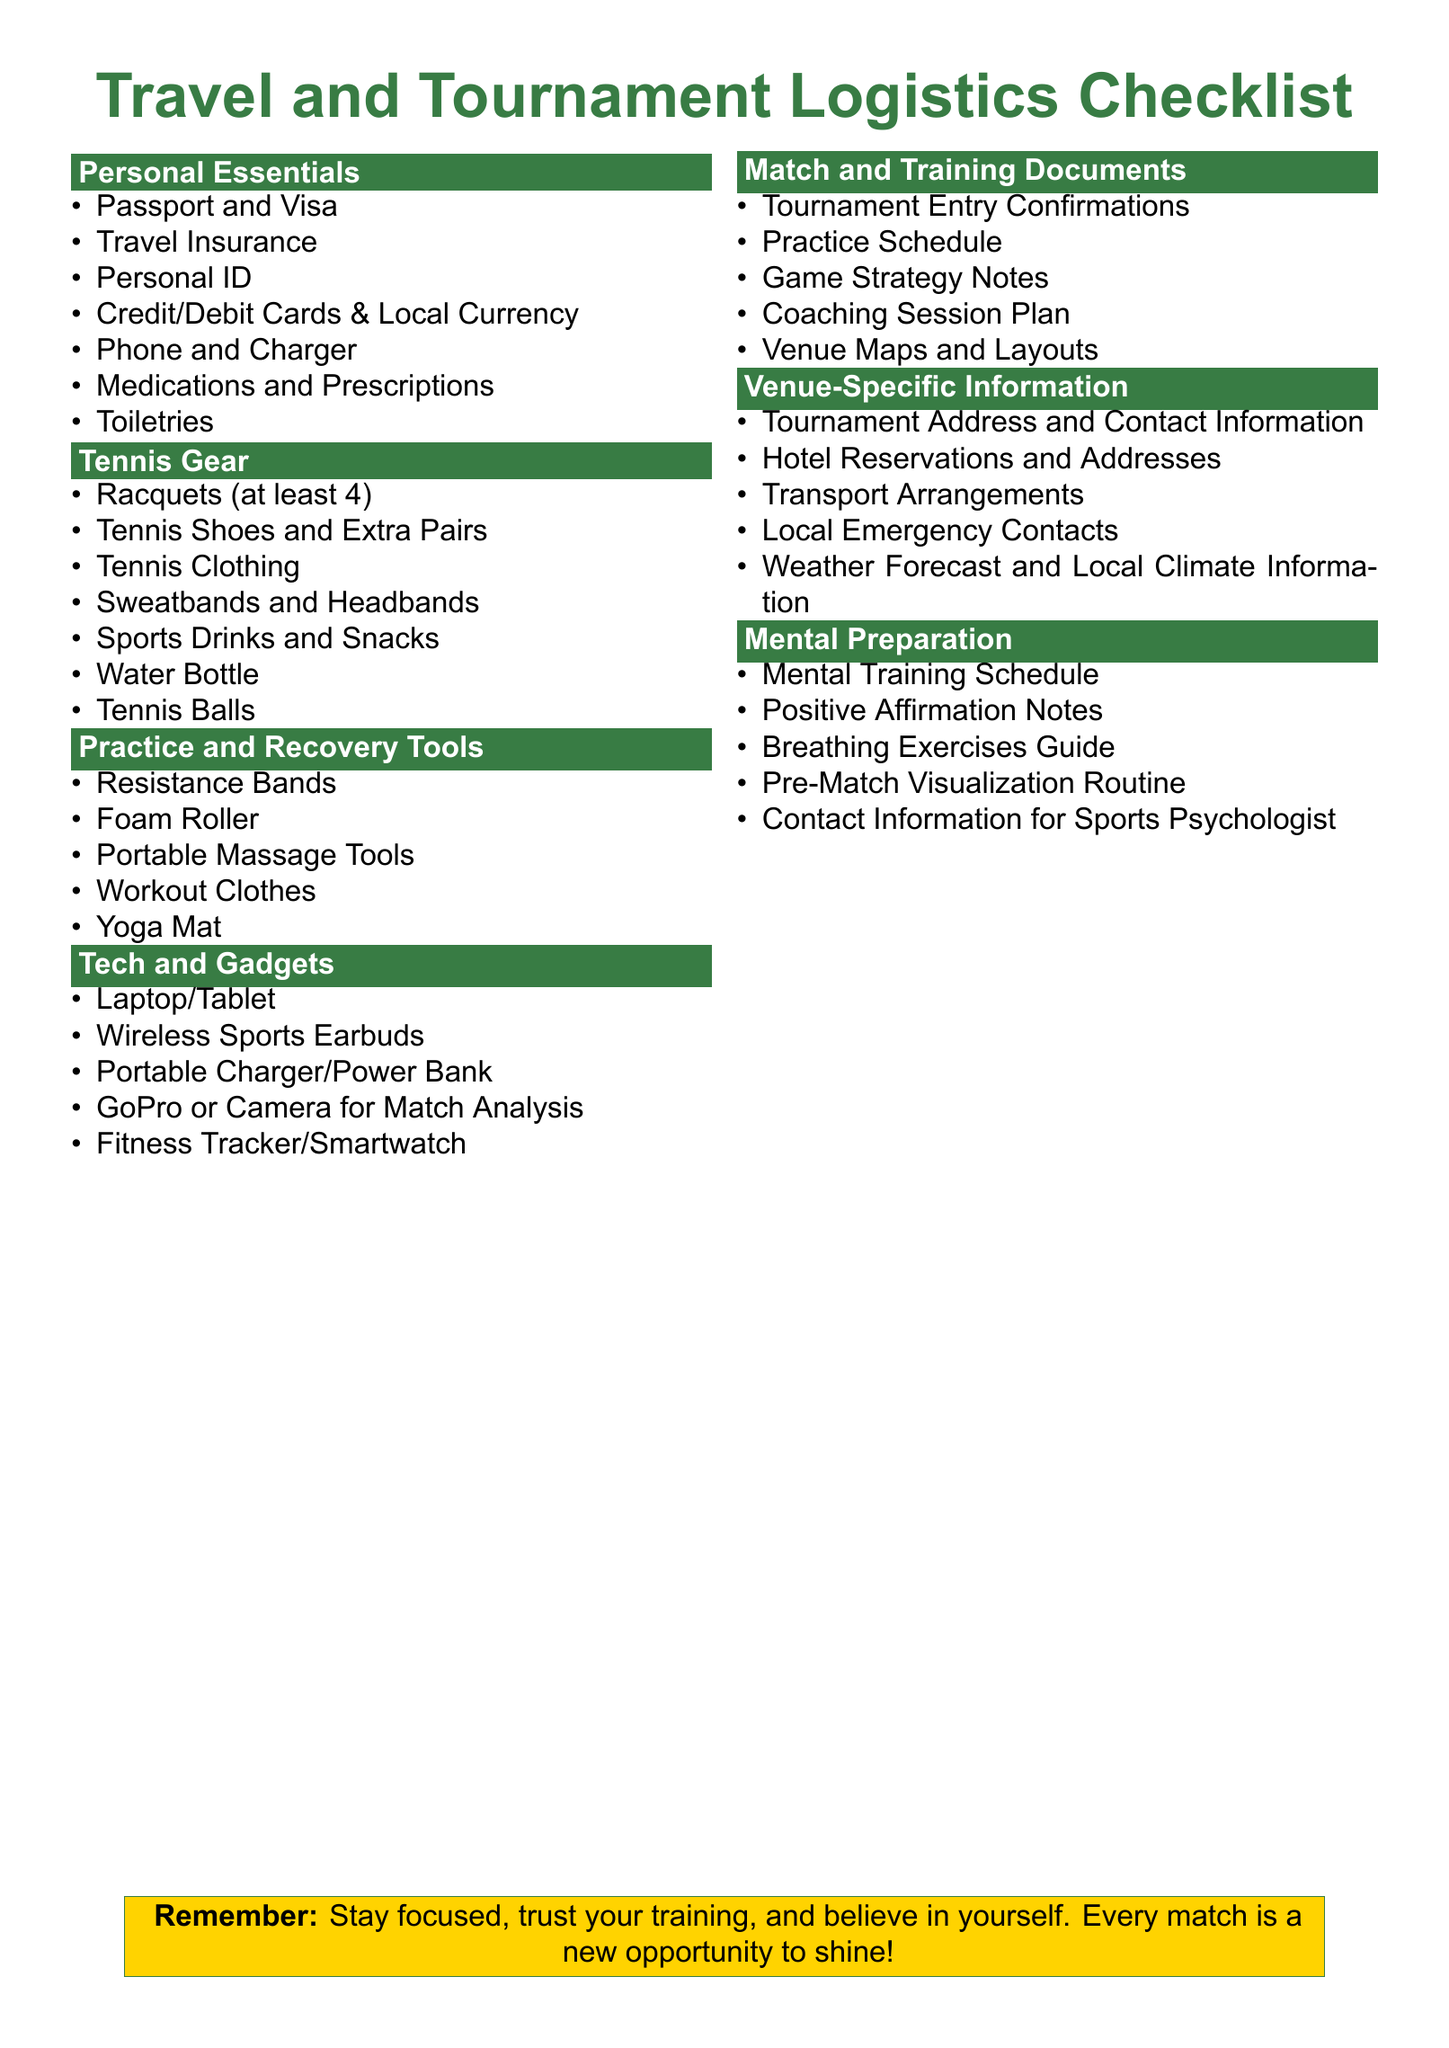what should I bring for personal essentials? The document lists items under "Personal Essentials," which include Passport, Travel Insurance, Personal ID, Credit/Debit Cards, Phone, and more.
Answer: Passport and Visa how many racquets should I pack? The section on "Tennis Gear" states that at least 4 racquets should be included in your inventory.
Answer: 4 what type of clothing is recommended for practice? The "Practice and Recovery Tools" section mentions packing Workout Clothes.
Answer: Workout Clothes what tech gadget should I take for match analysis? The "Tech and Gadgets" section suggests bringing a GoPro or Camera for Match Analysis.
Answer: GoPro or Camera how is the weather forecast important for travel? The "Venue-Specific Information" includes Weather Forecast and Local Climate Information, which is crucial for planning.
Answer: Weather Forecast and Local Climate Information what resources are available for mental preparation? The "Mental Preparation" section includes items like Positive Affirmation Notes and Breathing Exercises Guide to help with focus and calmness.
Answer: Positive Affirmation Notes what venue-related details should I keep handy? The document contains important details about Tournament Address and Local Emergency Contacts under "Venue-Specific Information."
Answer: Tournament Address and Contact Information is there a specific number of tennis shoes to pack? The "Tennis Gear" section does not specify a number, but advises packing Tennis Shoes and Extra Pairs.
Answer: Extra Pairs what type of energy supplies should I have on hand? The "Tennis Gear" mentions packing Sports Drinks and Snacks for energy during matches.
Answer: Sports Drinks and Snacks 